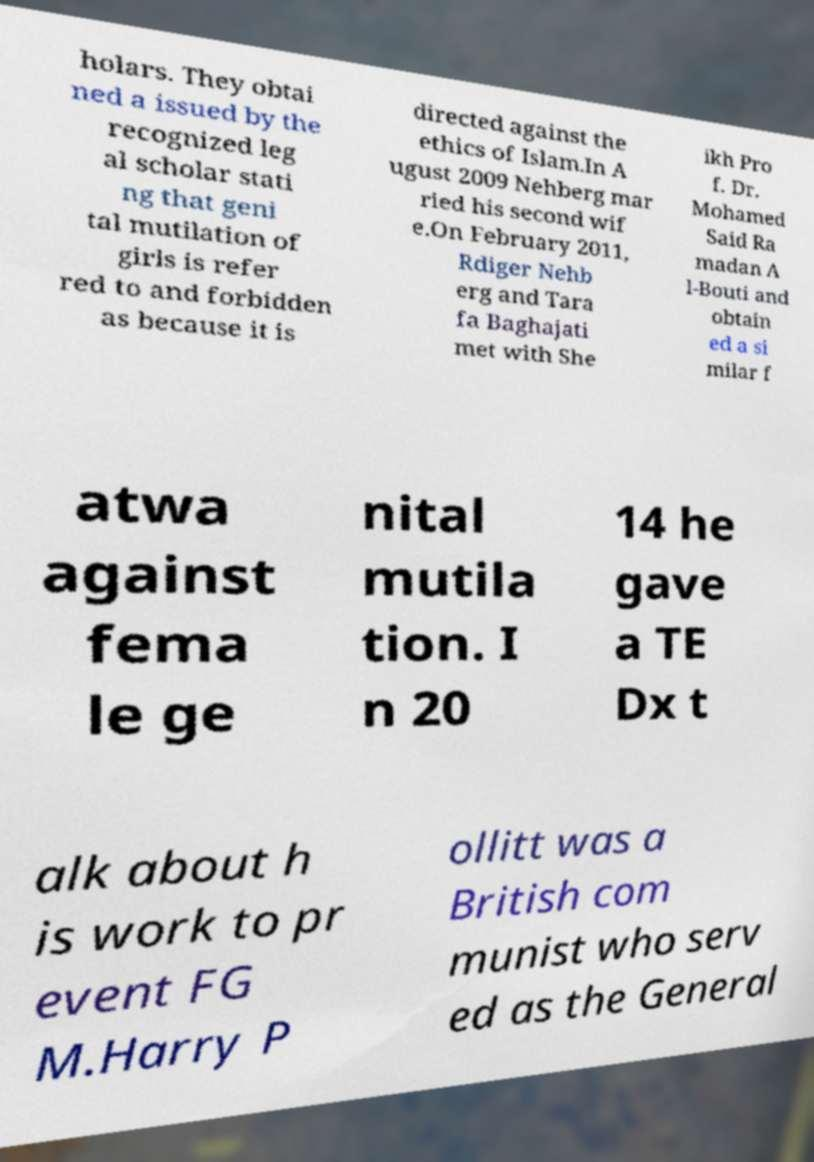Can you read and provide the text displayed in the image?This photo seems to have some interesting text. Can you extract and type it out for me? holars. They obtai ned a issued by the recognized leg al scholar stati ng that geni tal mutilation of girls is refer red to and forbidden as because it is directed against the ethics of Islam.In A ugust 2009 Nehberg mar ried his second wif e.On February 2011, Rdiger Nehb erg and Tara fa Baghajati met with She ikh Pro f. Dr. Mohamed Said Ra madan A l-Bouti and obtain ed a si milar f atwa against fema le ge nital mutila tion. I n 20 14 he gave a TE Dx t alk about h is work to pr event FG M.Harry P ollitt was a British com munist who serv ed as the General 